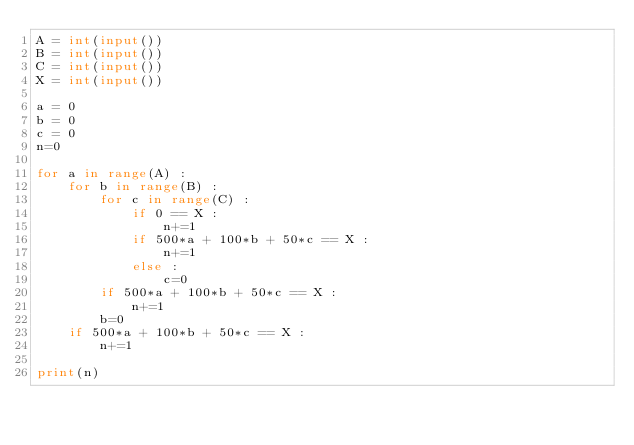Convert code to text. <code><loc_0><loc_0><loc_500><loc_500><_Python_>A = int(input())
B = int(input())
C = int(input())
X = int(input())

a = 0
b = 0
c = 0
n=0

for a in range(A) :
    for b in range(B) :
        for c in range(C) :
            if 0 == X :
                n+=1
            if 500*a + 100*b + 50*c == X :
                n+=1
            else :
                c=0
        if 500*a + 100*b + 50*c == X :
            n+=1
        b=0
    if 500*a + 100*b + 50*c == X :
        n+=1

print(n)
                </code> 